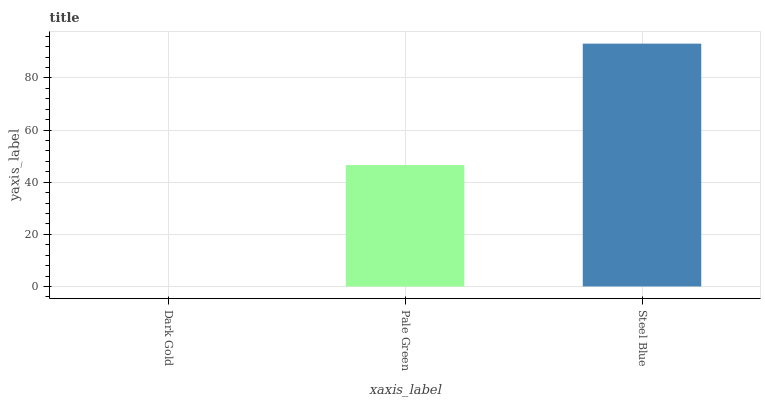Is Dark Gold the minimum?
Answer yes or no. Yes. Is Steel Blue the maximum?
Answer yes or no. Yes. Is Pale Green the minimum?
Answer yes or no. No. Is Pale Green the maximum?
Answer yes or no. No. Is Pale Green greater than Dark Gold?
Answer yes or no. Yes. Is Dark Gold less than Pale Green?
Answer yes or no. Yes. Is Dark Gold greater than Pale Green?
Answer yes or no. No. Is Pale Green less than Dark Gold?
Answer yes or no. No. Is Pale Green the high median?
Answer yes or no. Yes. Is Pale Green the low median?
Answer yes or no. Yes. Is Steel Blue the high median?
Answer yes or no. No. Is Dark Gold the low median?
Answer yes or no. No. 